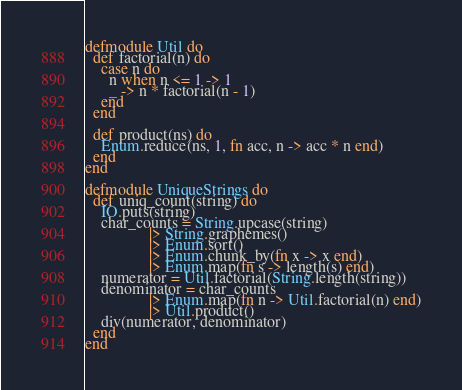Convert code to text. <code><loc_0><loc_0><loc_500><loc_500><_Elixir_>defmodule Util do
  def factorial(n) do
    case n do
      n when n <= 1 -> 1
      _ -> n * factorial(n - 1)
    end
  end

  def product(ns) do
    Enum.reduce(ns, 1, fn acc, n -> acc * n end)
  end
end

defmodule UniqueStrings do
  def uniq_count(string) do
    IO.puts(string)
    char_counts = String.upcase(string)
                |> String.graphemes()
                |> Enum.sort() 
                |> Enum.chunk_by(fn x -> x end) 
                |> Enum.map(fn s -> length(s) end)
    numerator = Util.factorial(String.length(string))
    denominator = char_counts 
                |> Enum.map(fn n -> Util.factorial(n) end)
                |> Util.product()
    div(numerator, denominator)
  end
end
</code> 